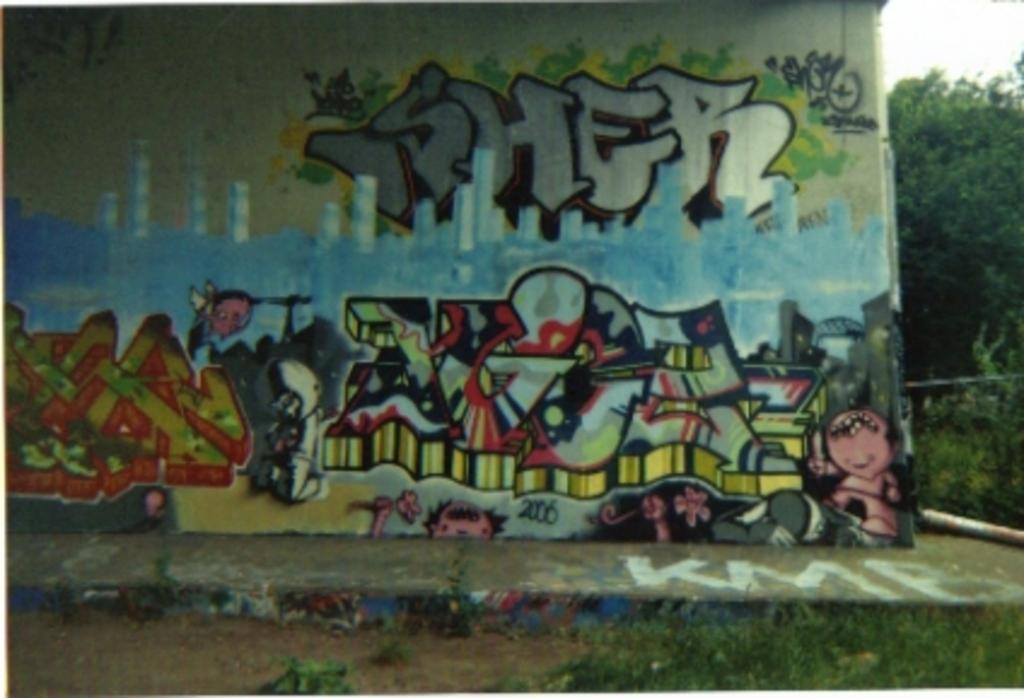What is painted in the image? There is a painted wall in the image. What type of vegetation can be seen in the image? Trees and grass are visible in the image. What color is the brain that is sitting on the seat in the image? There is no brain or seat present in the image; it only features a painted wall, trees, and grass. 